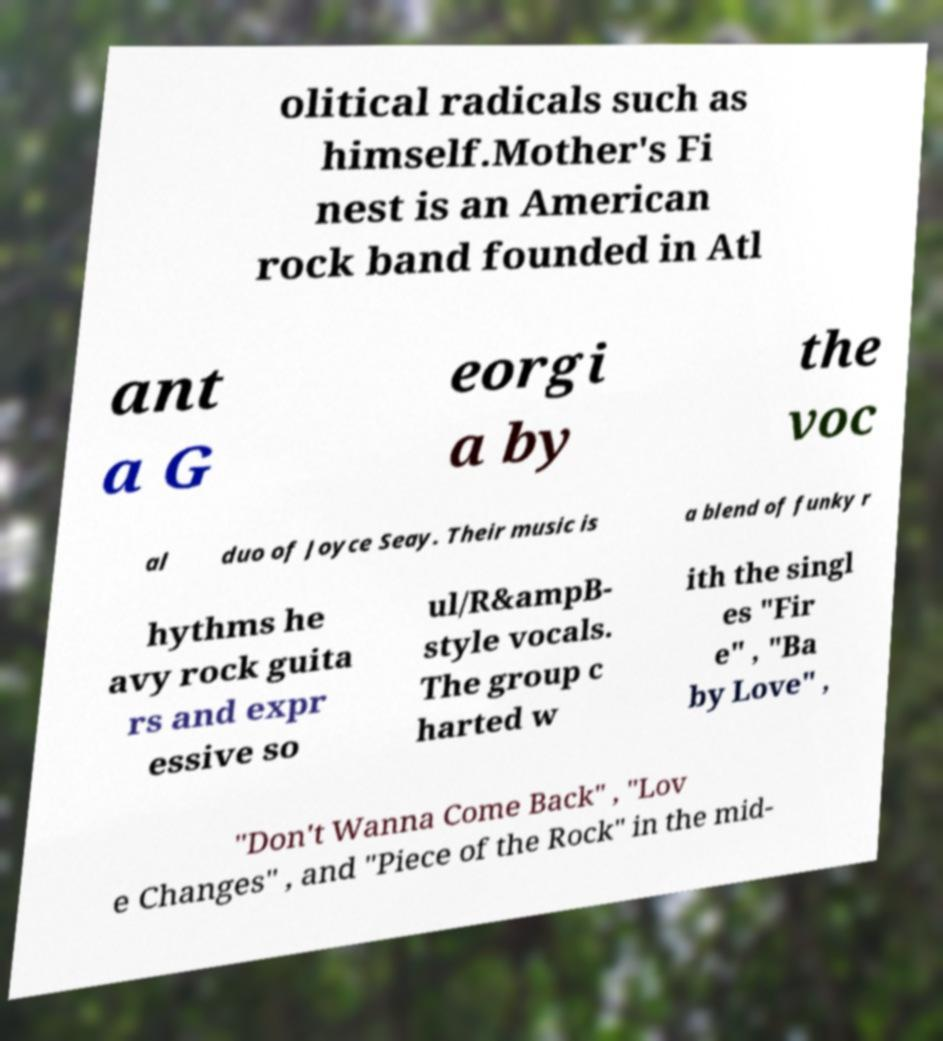There's text embedded in this image that I need extracted. Can you transcribe it verbatim? olitical radicals such as himself.Mother's Fi nest is an American rock band founded in Atl ant a G eorgi a by the voc al duo of Joyce Seay. Their music is a blend of funky r hythms he avy rock guita rs and expr essive so ul/R&ampB- style vocals. The group c harted w ith the singl es "Fir e" , "Ba by Love" , "Don't Wanna Come Back" , "Lov e Changes" , and "Piece of the Rock" in the mid- 